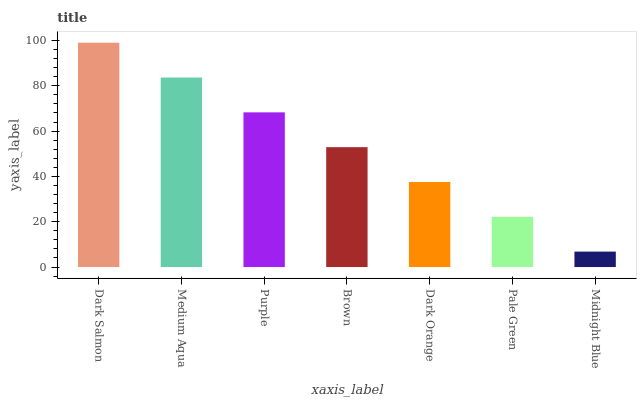Is Midnight Blue the minimum?
Answer yes or no. Yes. Is Dark Salmon the maximum?
Answer yes or no. Yes. Is Medium Aqua the minimum?
Answer yes or no. No. Is Medium Aqua the maximum?
Answer yes or no. No. Is Dark Salmon greater than Medium Aqua?
Answer yes or no. Yes. Is Medium Aqua less than Dark Salmon?
Answer yes or no. Yes. Is Medium Aqua greater than Dark Salmon?
Answer yes or no. No. Is Dark Salmon less than Medium Aqua?
Answer yes or no. No. Is Brown the high median?
Answer yes or no. Yes. Is Brown the low median?
Answer yes or no. Yes. Is Dark Orange the high median?
Answer yes or no. No. Is Midnight Blue the low median?
Answer yes or no. No. 